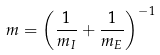<formula> <loc_0><loc_0><loc_500><loc_500>m = \left ( \frac { 1 } { m _ { I } } + \frac { 1 } { m _ { E } } \right ) ^ { - 1 }</formula> 